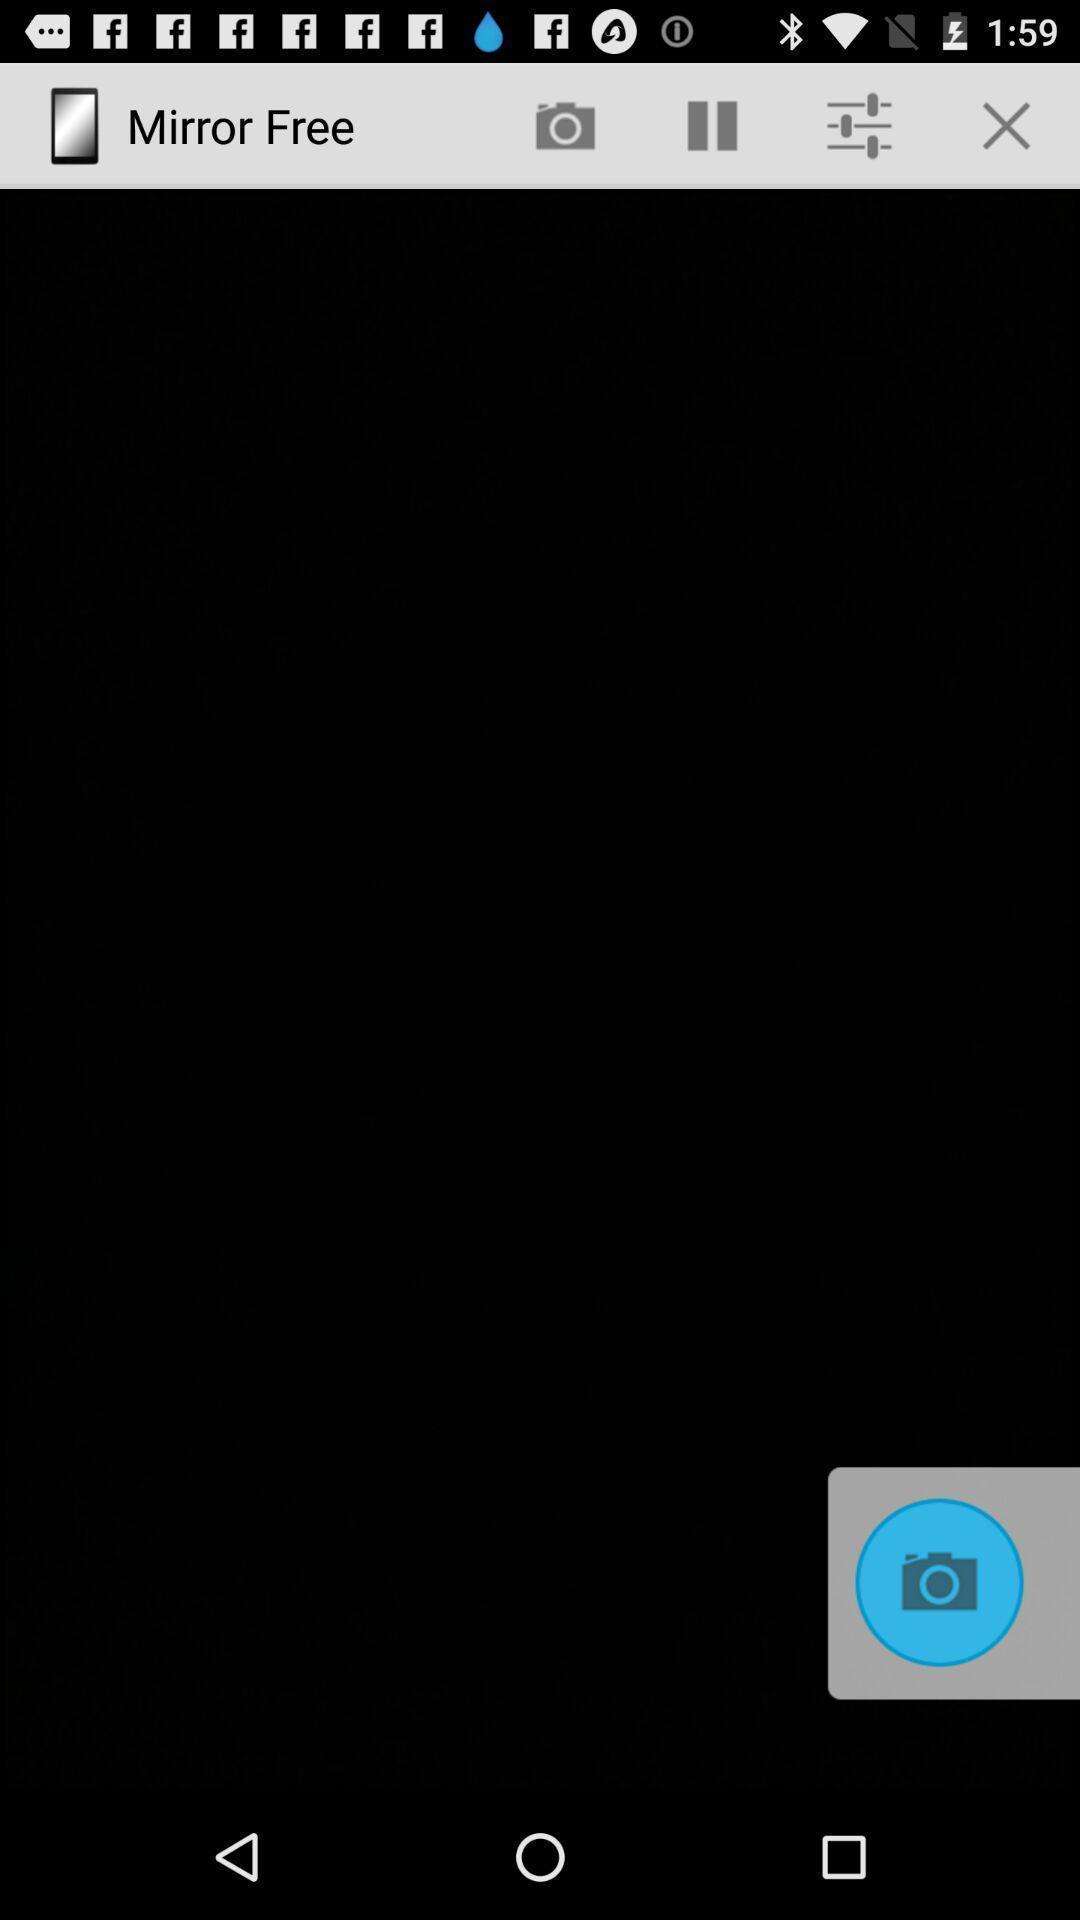Summarize the main components in this picture. Screen displaying a blank image with different edit options. 